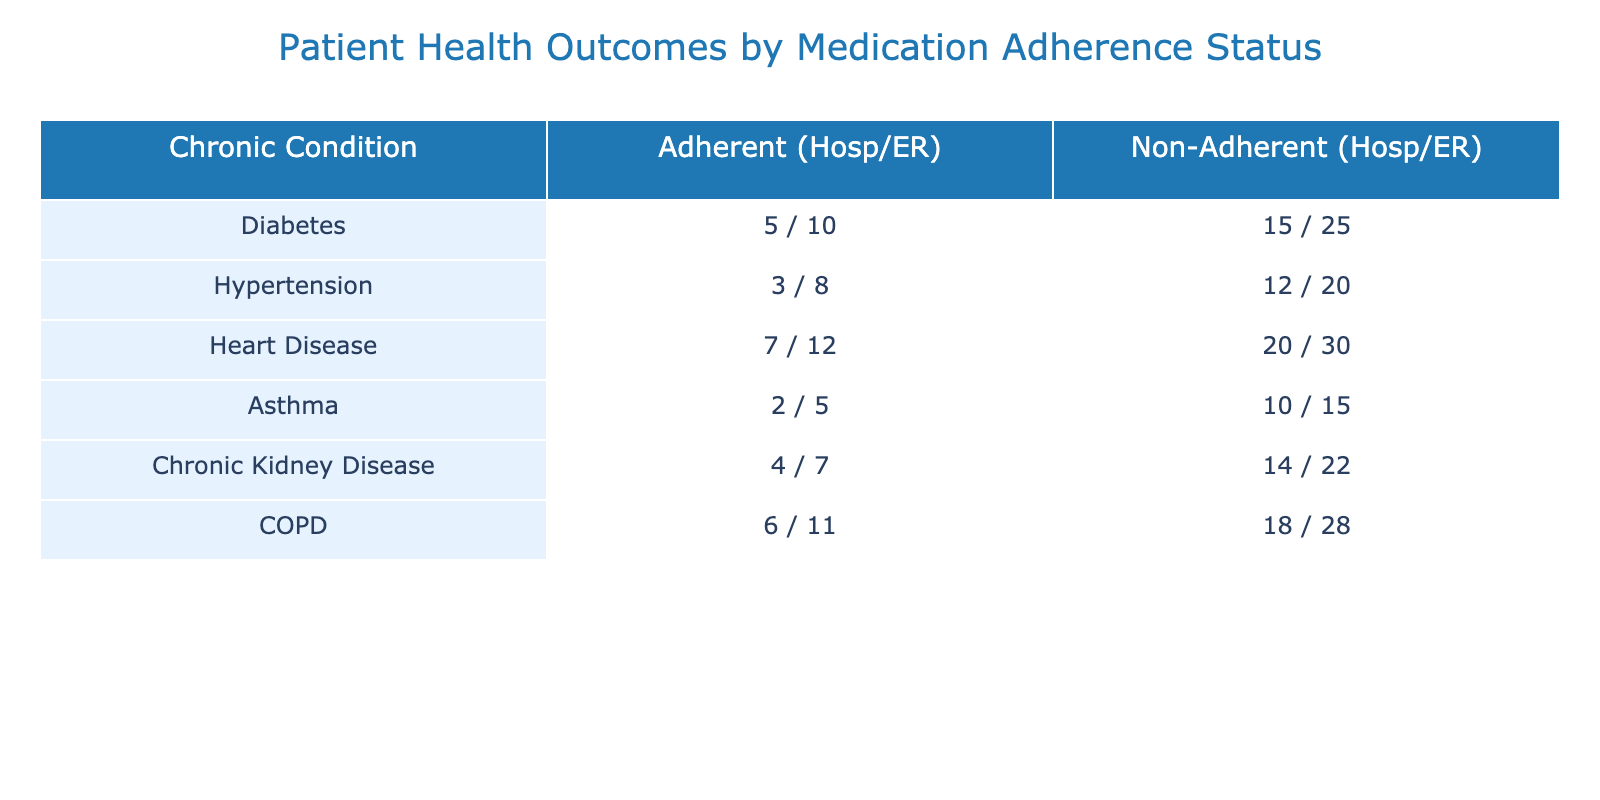What is the total number of hospitalizations for patients with Heart Disease? From the table, the number of hospitalizations for Heart Disease in adherent patients is 7 and for non-adherent patients is 20. We sum these values: 7 + 20 = 27.
Answer: 27 How many emergency visits do non-adherent patients with COPD have? The table indicates that non-adherent COPD patients have 28 emergency visits. This value can be directly retrieved from the table.
Answer: 28 What is the difference in the number of hospitalizations between non-adherent patients and adherent patients for hypertension? For non-adherent patients with hypertension, there are 12 hospitalizations, and for adherent patients, there are 3. The difference is calculated as 12 - 3 = 9.
Answer: 9 Are there more total emergency visits for non-adherent patients with diabetes than for adherent patients with heart disease? Non-adherent patients with diabetes have 25 emergency visits, while adherent patients with heart disease have 12. Since 25 is greater than 12, the statement is true.
Answer: Yes What is the combined total of hospitalizations for adherent asthma and chronic kidney disease patients? The number of hospitalizations for adherent asthma patients is 2, and for adherent chronic kidney disease patients, it is 4. Adding these gives a total of 2 + 4 = 6 hospitalizations.
Answer: 6 What percentage of emergency visits are accounted for by non-adherent diabetes patients relative to total emergency visits across all conditions? Non-adherent diabetes patients have 25 emergency visits. To find the total emergency visits, we sum all emergency visits: 10 + 25 + 8 + 20 + 12 + 30 + 5 + 15 + 7 + 22 + 11 + 28 = 288. The percentage is (25 / 288) * 100, which is approximately 8.68%.
Answer: 8.68% How many total hospitalizations are reported for adherent patients across all chronic conditions? By adding the hospitalizations of all adherent patients: 5 (Diabetes) + 3 (Hypertension) + 7 (Heart Disease) + 2 (Asthma) + 4 (Chronic Kidney Disease) + 6 (COPD) = 27 total hospitalizations for adherent patients.
Answer: 27 Which chronic condition has the highest number of hospitalizations for non-adherent patients? Non-adherent patients with heart disease have the highest number of hospitalizations at 20, which is the highest value when comparing all non-adherent groups.
Answer: Heart Disease 